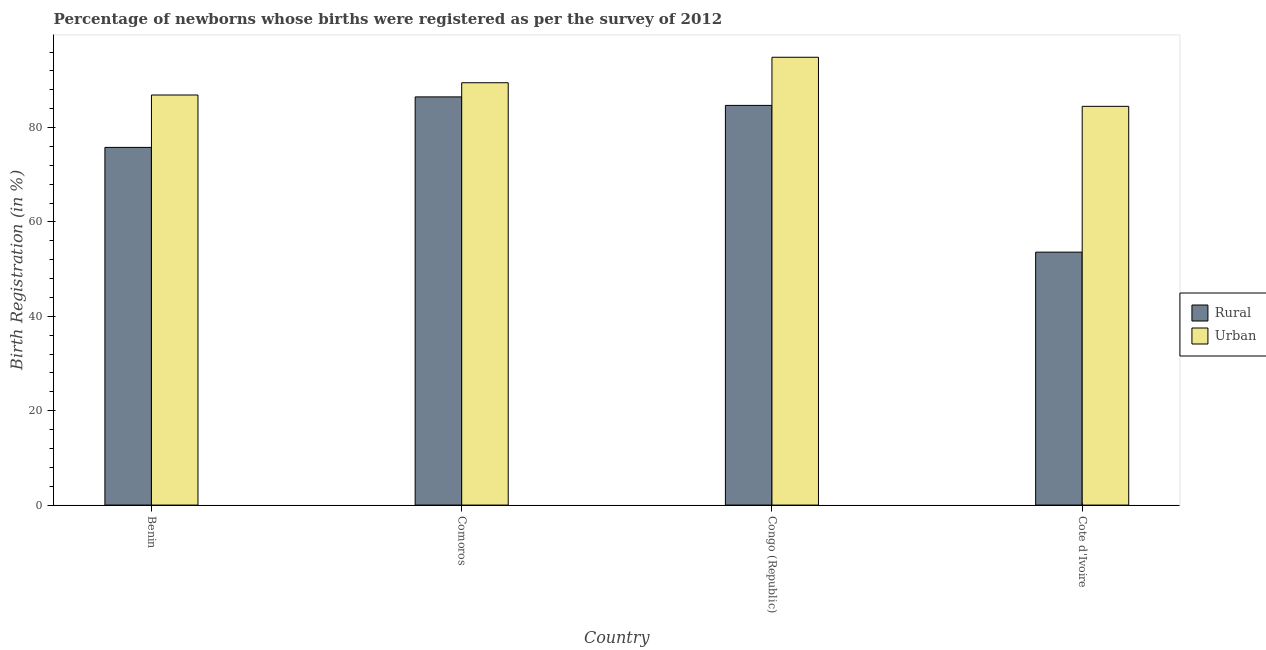How many different coloured bars are there?
Offer a terse response. 2. How many groups of bars are there?
Make the answer very short. 4. Are the number of bars on each tick of the X-axis equal?
Your answer should be compact. Yes. How many bars are there on the 2nd tick from the left?
Offer a terse response. 2. How many bars are there on the 2nd tick from the right?
Provide a short and direct response. 2. What is the label of the 3rd group of bars from the left?
Your response must be concise. Congo (Republic). What is the rural birth registration in Cote d'Ivoire?
Ensure brevity in your answer.  53.6. Across all countries, what is the maximum urban birth registration?
Provide a short and direct response. 94.9. Across all countries, what is the minimum rural birth registration?
Your answer should be compact. 53.6. In which country was the rural birth registration maximum?
Offer a very short reply. Comoros. In which country was the urban birth registration minimum?
Offer a terse response. Cote d'Ivoire. What is the total urban birth registration in the graph?
Provide a succinct answer. 355.8. What is the difference between the urban birth registration in Comoros and that in Cote d'Ivoire?
Give a very brief answer. 5. What is the difference between the rural birth registration in Comoros and the urban birth registration in Cote d'Ivoire?
Keep it short and to the point. 2. What is the average rural birth registration per country?
Provide a succinct answer. 75.15. What is the difference between the rural birth registration and urban birth registration in Cote d'Ivoire?
Your answer should be very brief. -30.9. In how many countries, is the rural birth registration greater than 48 %?
Your response must be concise. 4. What is the ratio of the urban birth registration in Congo (Republic) to that in Cote d'Ivoire?
Your response must be concise. 1.12. Is the rural birth registration in Benin less than that in Cote d'Ivoire?
Give a very brief answer. No. Is the difference between the urban birth registration in Comoros and Cote d'Ivoire greater than the difference between the rural birth registration in Comoros and Cote d'Ivoire?
Your answer should be compact. No. What is the difference between the highest and the second highest urban birth registration?
Provide a short and direct response. 5.4. What is the difference between the highest and the lowest rural birth registration?
Offer a terse response. 32.9. Is the sum of the urban birth registration in Benin and Congo (Republic) greater than the maximum rural birth registration across all countries?
Your answer should be very brief. Yes. What does the 2nd bar from the left in Cote d'Ivoire represents?
Provide a succinct answer. Urban. What does the 2nd bar from the right in Benin represents?
Offer a terse response. Rural. How many bars are there?
Ensure brevity in your answer.  8. Are all the bars in the graph horizontal?
Provide a succinct answer. No. What is the difference between two consecutive major ticks on the Y-axis?
Keep it short and to the point. 20. How many legend labels are there?
Ensure brevity in your answer.  2. What is the title of the graph?
Make the answer very short. Percentage of newborns whose births were registered as per the survey of 2012. Does "Researchers" appear as one of the legend labels in the graph?
Offer a terse response. No. What is the label or title of the Y-axis?
Make the answer very short. Birth Registration (in %). What is the Birth Registration (in %) in Rural in Benin?
Keep it short and to the point. 75.8. What is the Birth Registration (in %) in Urban in Benin?
Offer a terse response. 86.9. What is the Birth Registration (in %) of Rural in Comoros?
Provide a succinct answer. 86.5. What is the Birth Registration (in %) in Urban in Comoros?
Your response must be concise. 89.5. What is the Birth Registration (in %) of Rural in Congo (Republic)?
Keep it short and to the point. 84.7. What is the Birth Registration (in %) in Urban in Congo (Republic)?
Provide a succinct answer. 94.9. What is the Birth Registration (in %) of Rural in Cote d'Ivoire?
Keep it short and to the point. 53.6. What is the Birth Registration (in %) in Urban in Cote d'Ivoire?
Give a very brief answer. 84.5. Across all countries, what is the maximum Birth Registration (in %) of Rural?
Your answer should be very brief. 86.5. Across all countries, what is the maximum Birth Registration (in %) of Urban?
Your answer should be very brief. 94.9. Across all countries, what is the minimum Birth Registration (in %) in Rural?
Provide a short and direct response. 53.6. Across all countries, what is the minimum Birth Registration (in %) of Urban?
Your answer should be compact. 84.5. What is the total Birth Registration (in %) of Rural in the graph?
Offer a terse response. 300.6. What is the total Birth Registration (in %) in Urban in the graph?
Make the answer very short. 355.8. What is the difference between the Birth Registration (in %) of Rural in Benin and that in Comoros?
Provide a short and direct response. -10.7. What is the difference between the Birth Registration (in %) of Urban in Benin and that in Comoros?
Make the answer very short. -2.6. What is the difference between the Birth Registration (in %) of Rural in Benin and that in Congo (Republic)?
Keep it short and to the point. -8.9. What is the difference between the Birth Registration (in %) of Urban in Benin and that in Congo (Republic)?
Give a very brief answer. -8. What is the difference between the Birth Registration (in %) in Urban in Benin and that in Cote d'Ivoire?
Your answer should be compact. 2.4. What is the difference between the Birth Registration (in %) in Urban in Comoros and that in Congo (Republic)?
Provide a short and direct response. -5.4. What is the difference between the Birth Registration (in %) of Rural in Comoros and that in Cote d'Ivoire?
Offer a very short reply. 32.9. What is the difference between the Birth Registration (in %) of Rural in Congo (Republic) and that in Cote d'Ivoire?
Your response must be concise. 31.1. What is the difference between the Birth Registration (in %) of Rural in Benin and the Birth Registration (in %) of Urban in Comoros?
Give a very brief answer. -13.7. What is the difference between the Birth Registration (in %) of Rural in Benin and the Birth Registration (in %) of Urban in Congo (Republic)?
Provide a succinct answer. -19.1. What is the difference between the Birth Registration (in %) of Rural in Comoros and the Birth Registration (in %) of Urban in Congo (Republic)?
Make the answer very short. -8.4. What is the difference between the Birth Registration (in %) of Rural in Comoros and the Birth Registration (in %) of Urban in Cote d'Ivoire?
Make the answer very short. 2. What is the difference between the Birth Registration (in %) in Rural in Congo (Republic) and the Birth Registration (in %) in Urban in Cote d'Ivoire?
Your response must be concise. 0.2. What is the average Birth Registration (in %) of Rural per country?
Your response must be concise. 75.15. What is the average Birth Registration (in %) of Urban per country?
Ensure brevity in your answer.  88.95. What is the difference between the Birth Registration (in %) in Rural and Birth Registration (in %) in Urban in Comoros?
Your answer should be compact. -3. What is the difference between the Birth Registration (in %) of Rural and Birth Registration (in %) of Urban in Cote d'Ivoire?
Offer a very short reply. -30.9. What is the ratio of the Birth Registration (in %) in Rural in Benin to that in Comoros?
Give a very brief answer. 0.88. What is the ratio of the Birth Registration (in %) in Urban in Benin to that in Comoros?
Make the answer very short. 0.97. What is the ratio of the Birth Registration (in %) of Rural in Benin to that in Congo (Republic)?
Ensure brevity in your answer.  0.89. What is the ratio of the Birth Registration (in %) in Urban in Benin to that in Congo (Republic)?
Your answer should be compact. 0.92. What is the ratio of the Birth Registration (in %) in Rural in Benin to that in Cote d'Ivoire?
Ensure brevity in your answer.  1.41. What is the ratio of the Birth Registration (in %) in Urban in Benin to that in Cote d'Ivoire?
Your answer should be compact. 1.03. What is the ratio of the Birth Registration (in %) of Rural in Comoros to that in Congo (Republic)?
Provide a short and direct response. 1.02. What is the ratio of the Birth Registration (in %) in Urban in Comoros to that in Congo (Republic)?
Provide a short and direct response. 0.94. What is the ratio of the Birth Registration (in %) in Rural in Comoros to that in Cote d'Ivoire?
Keep it short and to the point. 1.61. What is the ratio of the Birth Registration (in %) of Urban in Comoros to that in Cote d'Ivoire?
Offer a terse response. 1.06. What is the ratio of the Birth Registration (in %) in Rural in Congo (Republic) to that in Cote d'Ivoire?
Provide a succinct answer. 1.58. What is the ratio of the Birth Registration (in %) of Urban in Congo (Republic) to that in Cote d'Ivoire?
Your answer should be compact. 1.12. What is the difference between the highest and the second highest Birth Registration (in %) of Urban?
Offer a terse response. 5.4. What is the difference between the highest and the lowest Birth Registration (in %) of Rural?
Keep it short and to the point. 32.9. 